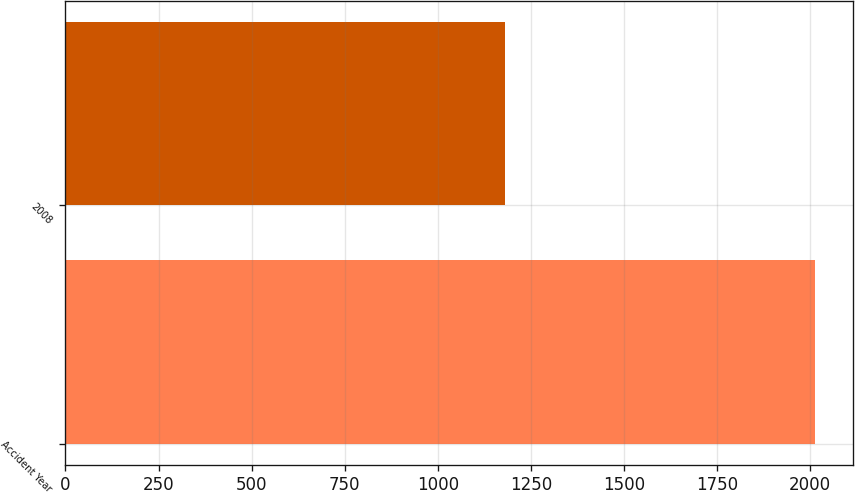Convert chart. <chart><loc_0><loc_0><loc_500><loc_500><bar_chart><fcel>Accident Year<fcel>2008<nl><fcel>2014<fcel>1181<nl></chart> 